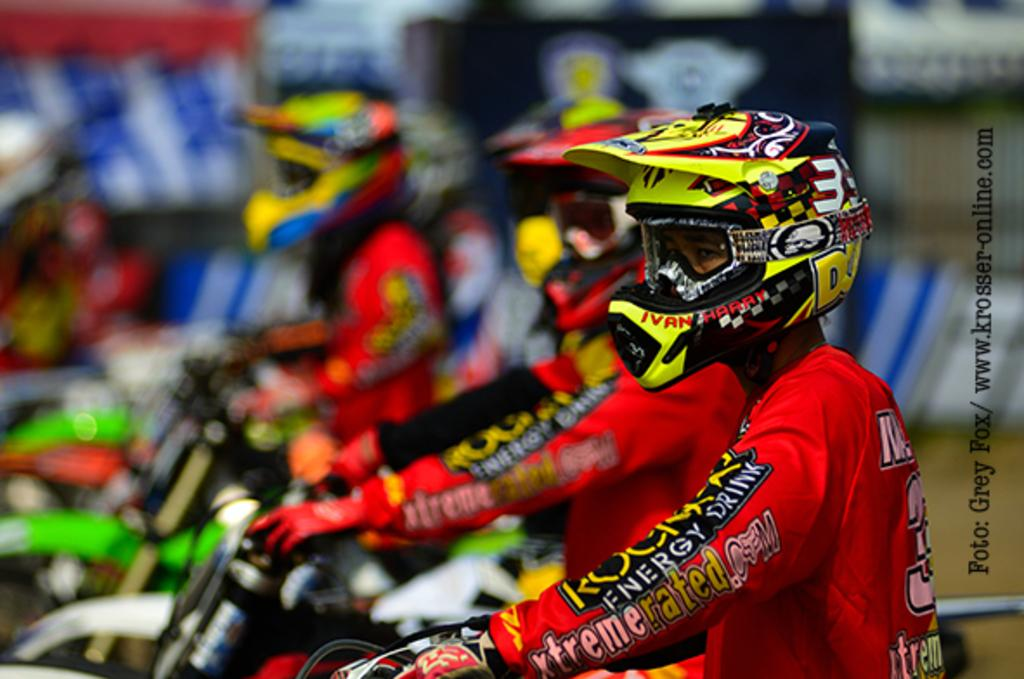What are the persons in the image doing? The persons in the image are riding bikes. What safety precaution are the persons taking while riding bikes? The persons are wearing helmets. What type of meal is being prepared on the hook in the image? There is no hook or meal present in the image; it features persons riding bikes while wearing helmets. 